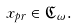Convert formula to latex. <formula><loc_0><loc_0><loc_500><loc_500>x _ { p r } \in { \mathfrak C } _ { \omega } .</formula> 